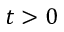Convert formula to latex. <formula><loc_0><loc_0><loc_500><loc_500>t > 0</formula> 